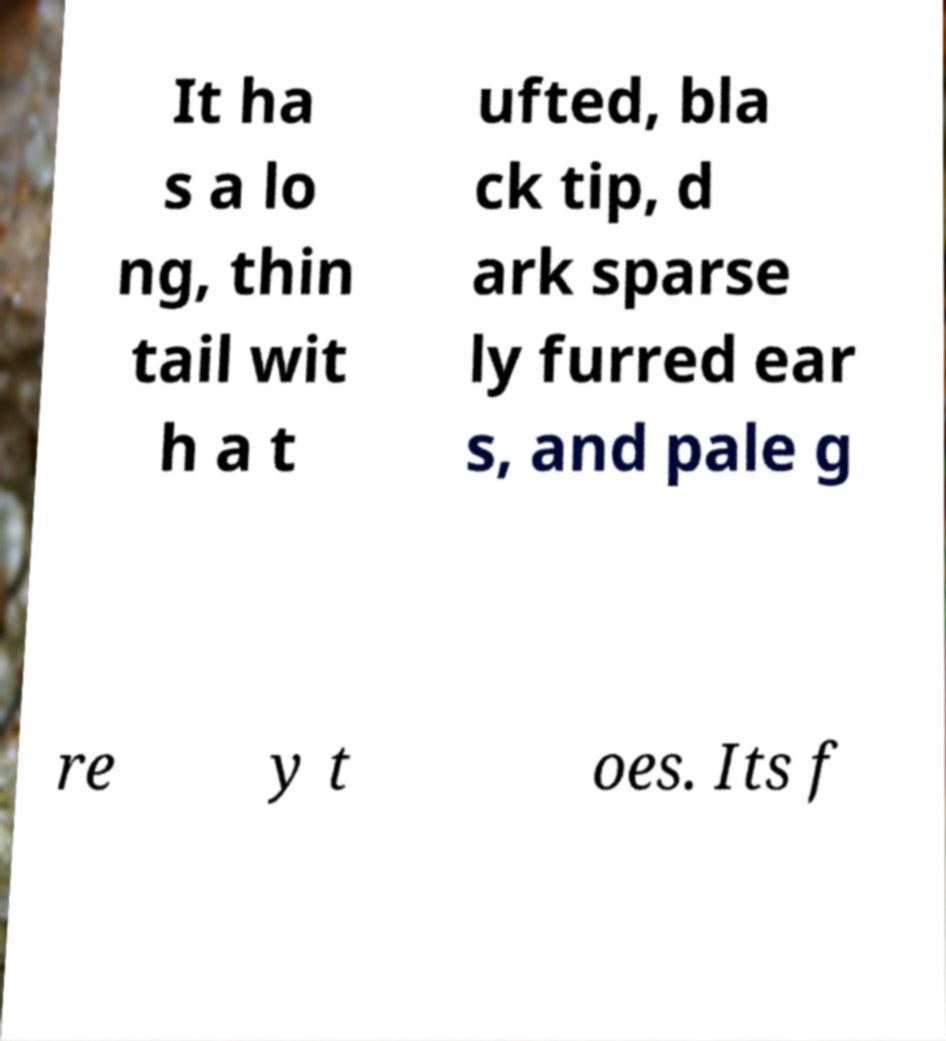Please read and relay the text visible in this image. What does it say? It ha s a lo ng, thin tail wit h a t ufted, bla ck tip, d ark sparse ly furred ear s, and pale g re y t oes. Its f 